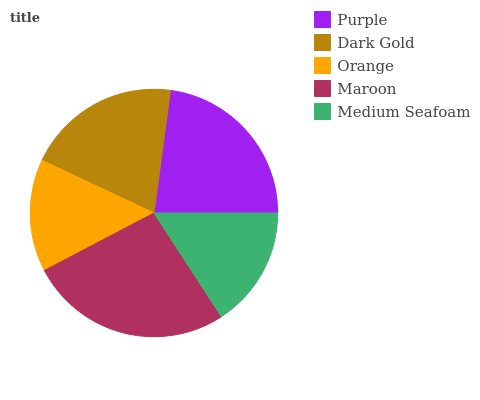Is Orange the minimum?
Answer yes or no. Yes. Is Maroon the maximum?
Answer yes or no. Yes. Is Dark Gold the minimum?
Answer yes or no. No. Is Dark Gold the maximum?
Answer yes or no. No. Is Purple greater than Dark Gold?
Answer yes or no. Yes. Is Dark Gold less than Purple?
Answer yes or no. Yes. Is Dark Gold greater than Purple?
Answer yes or no. No. Is Purple less than Dark Gold?
Answer yes or no. No. Is Dark Gold the high median?
Answer yes or no. Yes. Is Dark Gold the low median?
Answer yes or no. Yes. Is Purple the high median?
Answer yes or no. No. Is Maroon the low median?
Answer yes or no. No. 